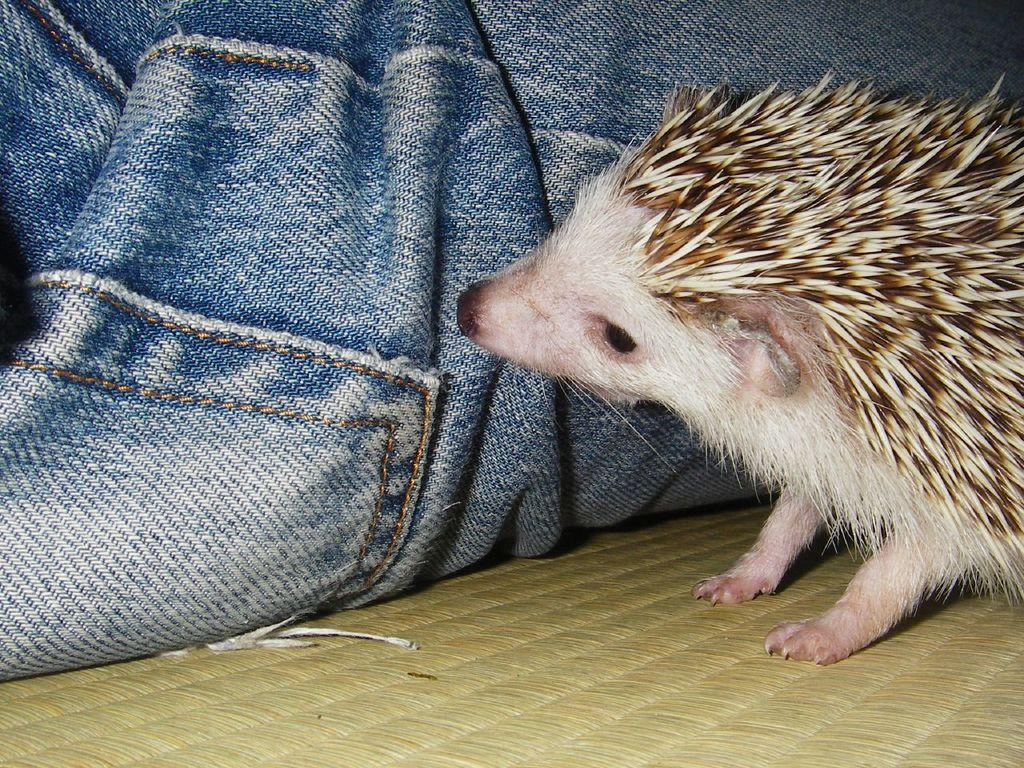What type of animal is in the image? The image contains an animal, but the specific type cannot be determined from the provided facts. What clothing item is present in the image? There are jeans cloth in the image. Where can the store be found in the image? There is no store present in the image. What type of crack is visible on the jeans cloth in the image? There is no crack visible on the jeans cloth in the image. 